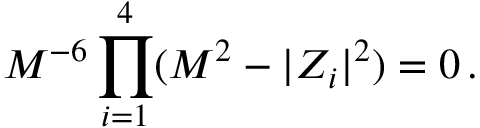Convert formula to latex. <formula><loc_0><loc_0><loc_500><loc_500>M ^ { - 6 } \prod _ { i = 1 } ^ { 4 } ( M ^ { 2 } - | Z _ { i } | ^ { 2 } ) = 0 \, .</formula> 